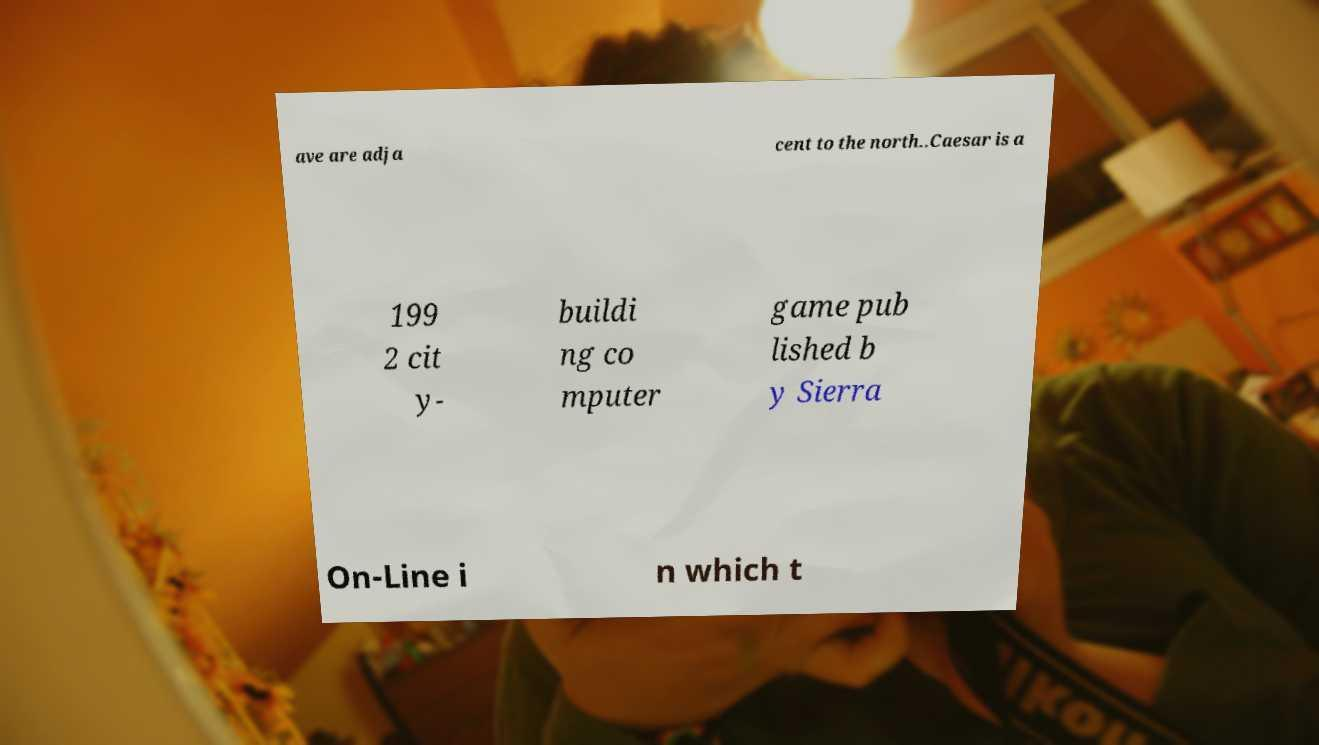What messages or text are displayed in this image? I need them in a readable, typed format. ave are adja cent to the north..Caesar is a 199 2 cit y- buildi ng co mputer game pub lished b y Sierra On-Line i n which t 